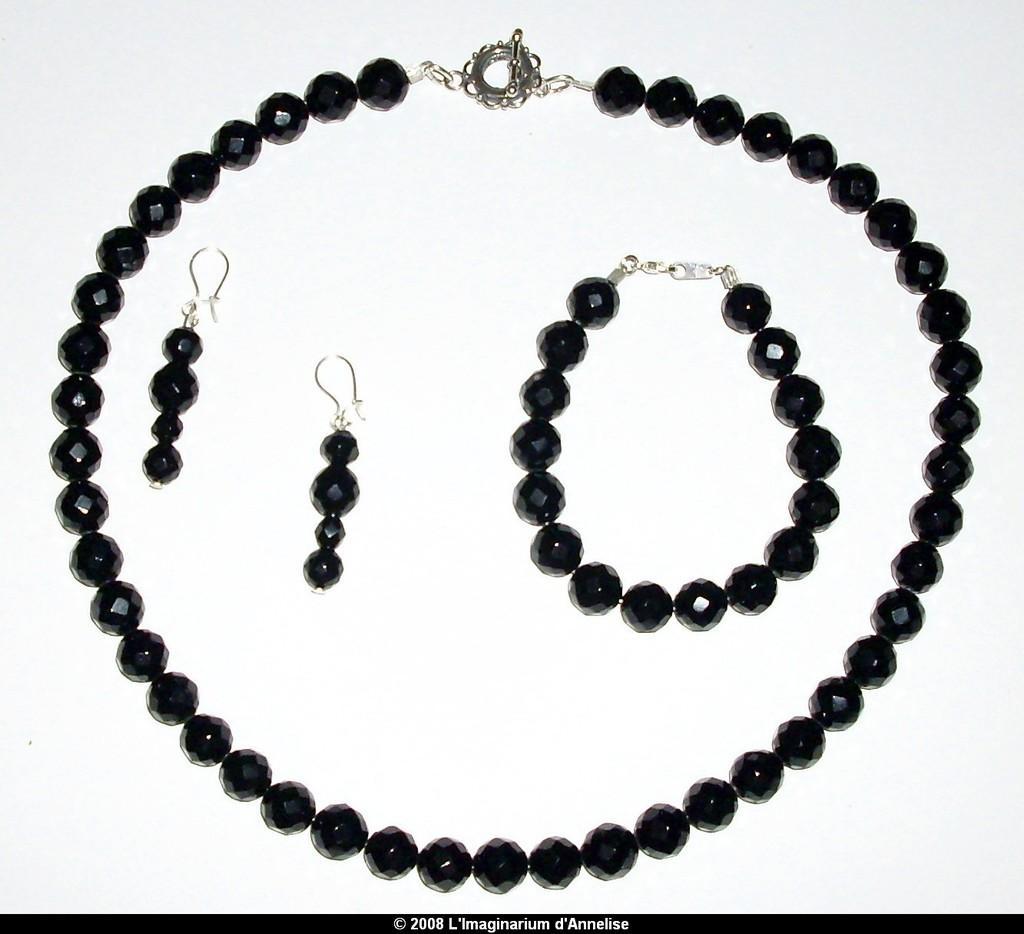Please provide a concise description of this image. In the center of the image we can see one necklace,bracelet and earrings,which are in black color. In the bottom of the image,we can see some text. 